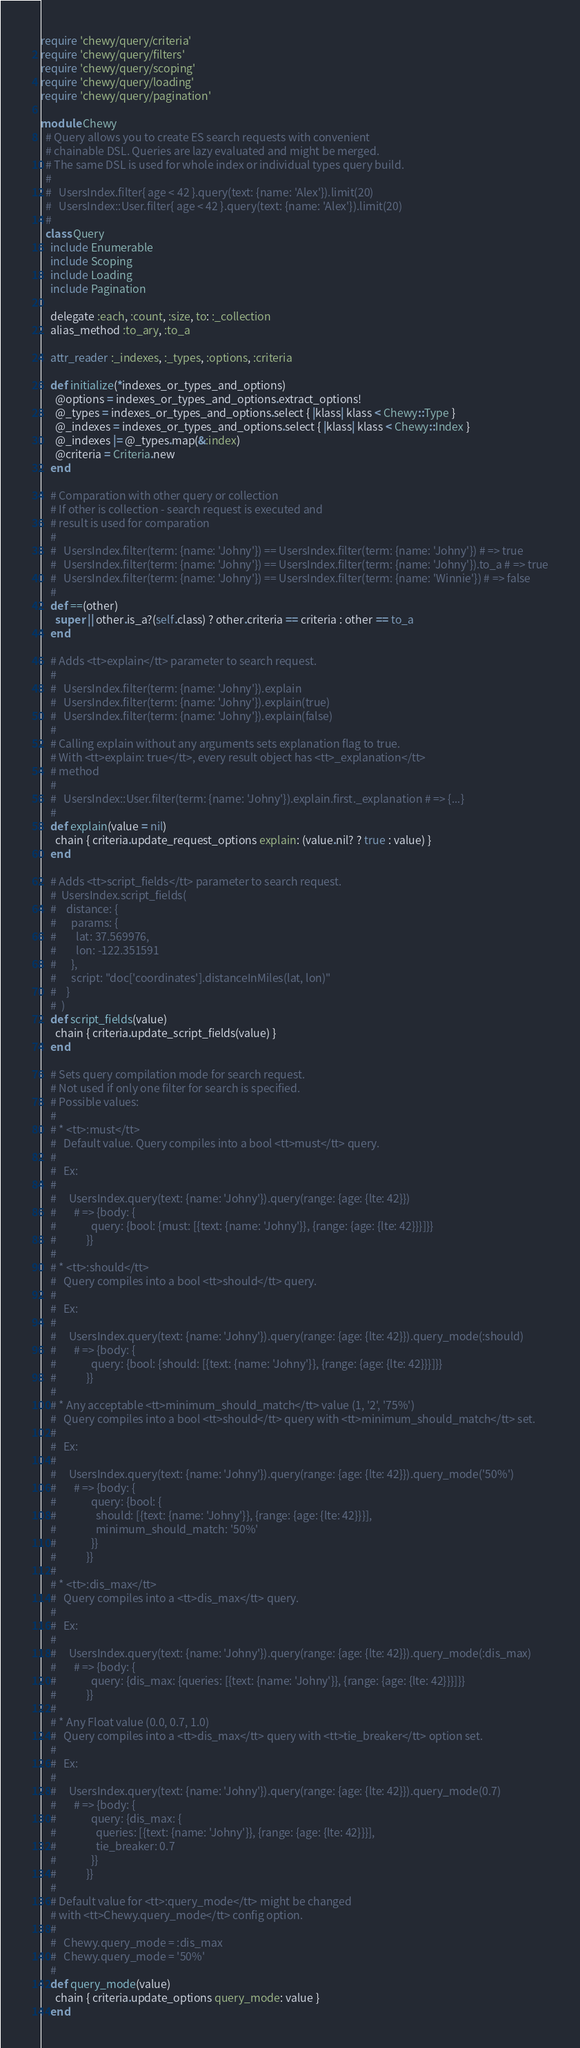Convert code to text. <code><loc_0><loc_0><loc_500><loc_500><_Ruby_>require 'chewy/query/criteria'
require 'chewy/query/filters'
require 'chewy/query/scoping'
require 'chewy/query/loading'
require 'chewy/query/pagination'

module Chewy
  # Query allows you to create ES search requests with convenient
  # chainable DSL. Queries are lazy evaluated and might be merged.
  # The same DSL is used for whole index or individual types query build.
  #
  #   UsersIndex.filter{ age < 42 }.query(text: {name: 'Alex'}).limit(20)
  #   UsersIndex::User.filter{ age < 42 }.query(text: {name: 'Alex'}).limit(20)
  #
  class Query
    include Enumerable
    include Scoping
    include Loading
    include Pagination

    delegate :each, :count, :size, to: :_collection
    alias_method :to_ary, :to_a

    attr_reader :_indexes, :_types, :options, :criteria

    def initialize(*indexes_or_types_and_options)
      @options = indexes_or_types_and_options.extract_options!
      @_types = indexes_or_types_and_options.select { |klass| klass < Chewy::Type }
      @_indexes = indexes_or_types_and_options.select { |klass| klass < Chewy::Index }
      @_indexes |= @_types.map(&:index)
      @criteria = Criteria.new
    end

    # Comparation with other query or collection
    # If other is collection - search request is executed and
    # result is used for comparation
    #
    #   UsersIndex.filter(term: {name: 'Johny'}) == UsersIndex.filter(term: {name: 'Johny'}) # => true
    #   UsersIndex.filter(term: {name: 'Johny'}) == UsersIndex.filter(term: {name: 'Johny'}).to_a # => true
    #   UsersIndex.filter(term: {name: 'Johny'}) == UsersIndex.filter(term: {name: 'Winnie'}) # => false
    #
    def ==(other)
      super || other.is_a?(self.class) ? other.criteria == criteria : other == to_a
    end

    # Adds <tt>explain</tt> parameter to search request.
    #
    #   UsersIndex.filter(term: {name: 'Johny'}).explain
    #   UsersIndex.filter(term: {name: 'Johny'}).explain(true)
    #   UsersIndex.filter(term: {name: 'Johny'}).explain(false)
    #
    # Calling explain without any arguments sets explanation flag to true.
    # With <tt>explain: true</tt>, every result object has <tt>_explanation</tt>
    # method
    #
    #   UsersIndex::User.filter(term: {name: 'Johny'}).explain.first._explanation # => {...}
    #
    def explain(value = nil)
      chain { criteria.update_request_options explain: (value.nil? ? true : value) }
    end

    # Adds <tt>script_fields</tt> parameter to search request.
    #  UsersIndex.script_fields(
    #    distance: {
    #      params: {
    #        lat: 37.569976,
    #        lon: -122.351591
    #      },
    #      script: "doc['coordinates'].distanceInMiles(lat, lon)"
    #    }
    #  )
    def script_fields(value)
      chain { criteria.update_script_fields(value) }
    end

    # Sets query compilation mode for search request.
    # Not used if only one filter for search is specified.
    # Possible values:
    #
    # * <tt>:must</tt>
    #   Default value. Query compiles into a bool <tt>must</tt> query.
    #
    #   Ex:
    #
    #     UsersIndex.query(text: {name: 'Johny'}).query(range: {age: {lte: 42}})
    #       # => {body: {
    #              query: {bool: {must: [{text: {name: 'Johny'}}, {range: {age: {lte: 42}}}]}}
    #            }}
    #
    # * <tt>:should</tt>
    #   Query compiles into a bool <tt>should</tt> query.
    #
    #   Ex:
    #
    #     UsersIndex.query(text: {name: 'Johny'}).query(range: {age: {lte: 42}}).query_mode(:should)
    #       # => {body: {
    #              query: {bool: {should: [{text: {name: 'Johny'}}, {range: {age: {lte: 42}}}]}}
    #            }}
    #
    # * Any acceptable <tt>minimum_should_match</tt> value (1, '2', '75%')
    #   Query compiles into a bool <tt>should</tt> query with <tt>minimum_should_match</tt> set.
    #
    #   Ex:
    #
    #     UsersIndex.query(text: {name: 'Johny'}).query(range: {age: {lte: 42}}).query_mode('50%')
    #       # => {body: {
    #              query: {bool: {
    #                should: [{text: {name: 'Johny'}}, {range: {age: {lte: 42}}}],
    #                minimum_should_match: '50%'
    #              }}
    #            }}
    #
    # * <tt>:dis_max</tt>
    #   Query compiles into a <tt>dis_max</tt> query.
    #
    #   Ex:
    #
    #     UsersIndex.query(text: {name: 'Johny'}).query(range: {age: {lte: 42}}).query_mode(:dis_max)
    #       # => {body: {
    #              query: {dis_max: {queries: [{text: {name: 'Johny'}}, {range: {age: {lte: 42}}}]}}
    #            }}
    #
    # * Any Float value (0.0, 0.7, 1.0)
    #   Query compiles into a <tt>dis_max</tt> query with <tt>tie_breaker</tt> option set.
    #
    #   Ex:
    #
    #     UsersIndex.query(text: {name: 'Johny'}).query(range: {age: {lte: 42}}).query_mode(0.7)
    #       # => {body: {
    #              query: {dis_max: {
    #                queries: [{text: {name: 'Johny'}}, {range: {age: {lte: 42}}}],
    #                tie_breaker: 0.7
    #              }}
    #            }}
    #
    # Default value for <tt>:query_mode</tt> might be changed
    # with <tt>Chewy.query_mode</tt> config option.
    #
    #   Chewy.query_mode = :dis_max
    #   Chewy.query_mode = '50%'
    #
    def query_mode(value)
      chain { criteria.update_options query_mode: value }
    end
</code> 